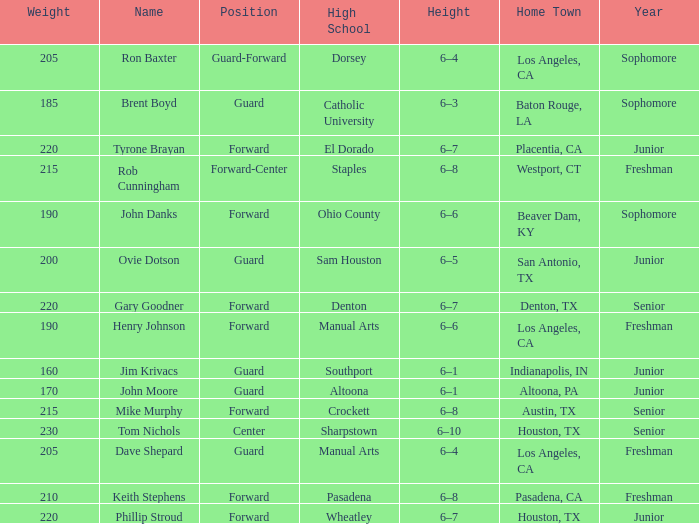What is the name along with a year of a junior, and a high school connected to wheatley? Phillip Stroud. 